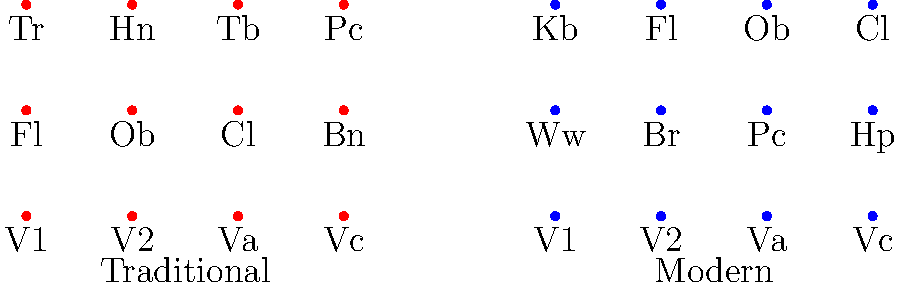Based on the seating arrangement diagram shown, which instrumental section has significantly changed its position from the traditional Hungarian orchestra to the modern symphony orchestra? To answer this question, we need to compare the positions of instrument sections in both arrangements:

1. String section (V1, V2, Va, Vc):
   - Traditional: Front row
   - Modern: Front row
   No significant change

2. Woodwinds (Fl, Ob, Cl, Bn):
   - Traditional: Second row
   - Modern: Consolidated as "Ww" in second row, with some individual instruments (Fl, Ob, Cl) moved to the back
   Some reorganization, but not a drastic change in position

3. Brass (Tr, Hn, Tb):
   - Traditional: Back row
   - Modern: Consolidated as "Br" in second row
   Moved forward, but not a drastic change

4. Percussion (Pc):
   - Traditional: Back row, right side
   - Modern: Second row, center
   Slight change, but not significantly

5. New additions in Modern:
   - Harp (Hp): Second row
   - Double Bass (Kb): Back row

The most significant change is the addition of new instruments (Harp and Double Bass) and the reorganization of woodwinds. However, the question asks for a section that has significantly changed its position.

Looking at the individual instruments, we can see that the flute (Fl), oboe (Ob), and clarinet (Cl) have moved from the second row in the traditional arrangement to the back row in the modern arrangement. This represents the most significant positional change among the sections.
Answer: Woodwinds 